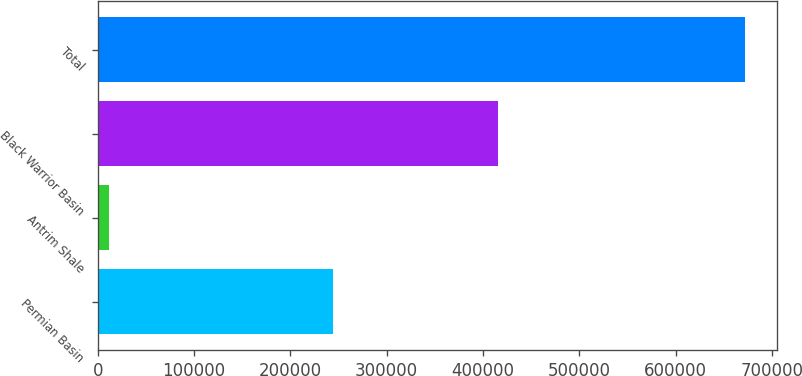<chart> <loc_0><loc_0><loc_500><loc_500><bar_chart><fcel>Permian Basin<fcel>Antrim Shale<fcel>Black Warrior Basin<fcel>Total<nl><fcel>244034<fcel>12114<fcel>415909<fcel>672057<nl></chart> 